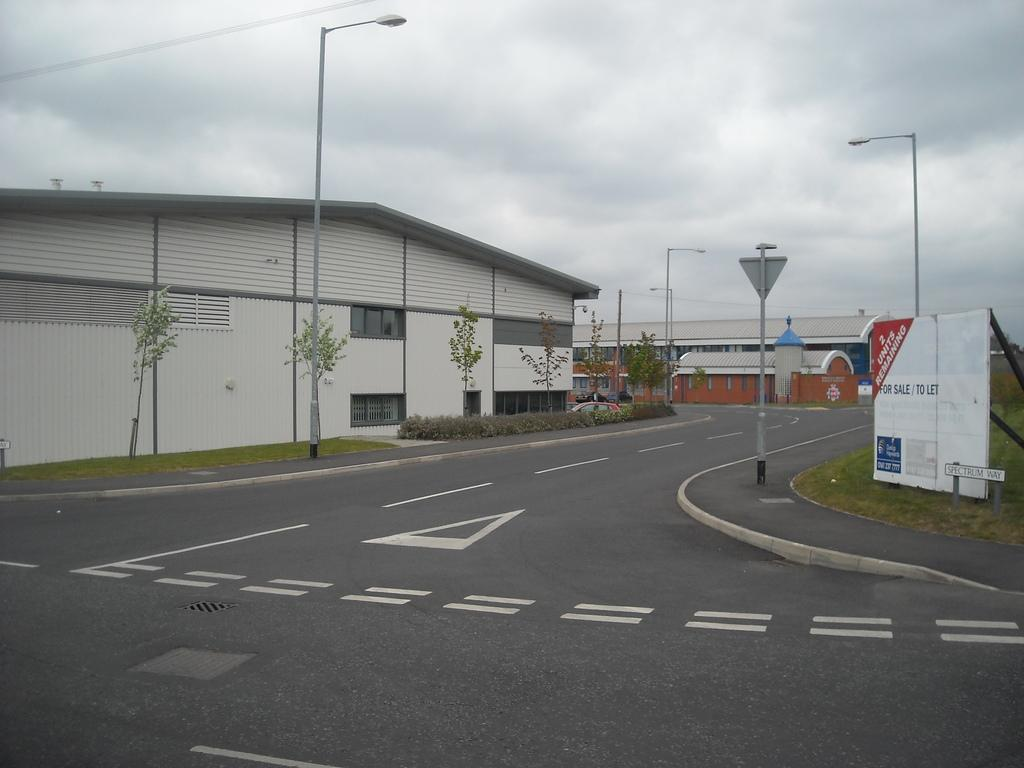What types of structures can be seen in the image? There are buildings in the image. What else can be seen moving in the image? There are vehicles in the image. What type of natural elements are present in the image? There are trees, plants, and grass in the image. What type of man-made objects can be seen in the image? There are poles in the image. What type of signage is present in the image? There are boards with text in the image. What is visible beneath the structures and vehicles in the image? The ground is visible in the image. What is visible in the sky in the image? The sky is visible in the image, and there are clouds in the sky. What type of club can be seen in the image? There is no club present in the image. What hope does the image offer for a better future? The image does not offer any hope for a better future, as it is a static representation of a scene. 